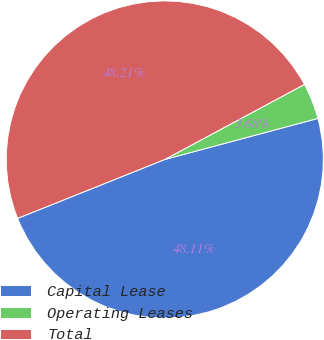Convert chart to OTSL. <chart><loc_0><loc_0><loc_500><loc_500><pie_chart><fcel>Capital Lease<fcel>Operating Leases<fcel>Total<nl><fcel>48.11%<fcel>3.68%<fcel>48.21%<nl></chart> 